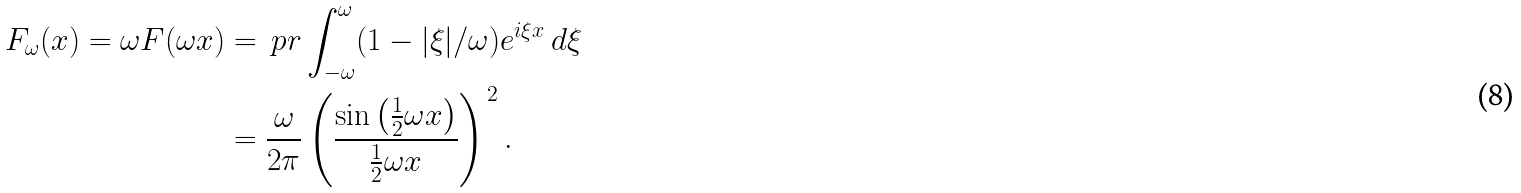Convert formula to latex. <formula><loc_0><loc_0><loc_500><loc_500>F _ { \omega } ( x ) = \omega F ( \omega x ) & = \ p r \int _ { - \omega } ^ { \omega } ( 1 - | \xi | / \omega ) e ^ { i \xi x } \, d \xi \\ & = \frac { \omega } { 2 \pi } \left ( \frac { \sin \left ( \frac { 1 } { 2 } \omega x \right ) } { \frac { 1 } { 2 } \omega x } \right ) ^ { \, 2 } .</formula> 